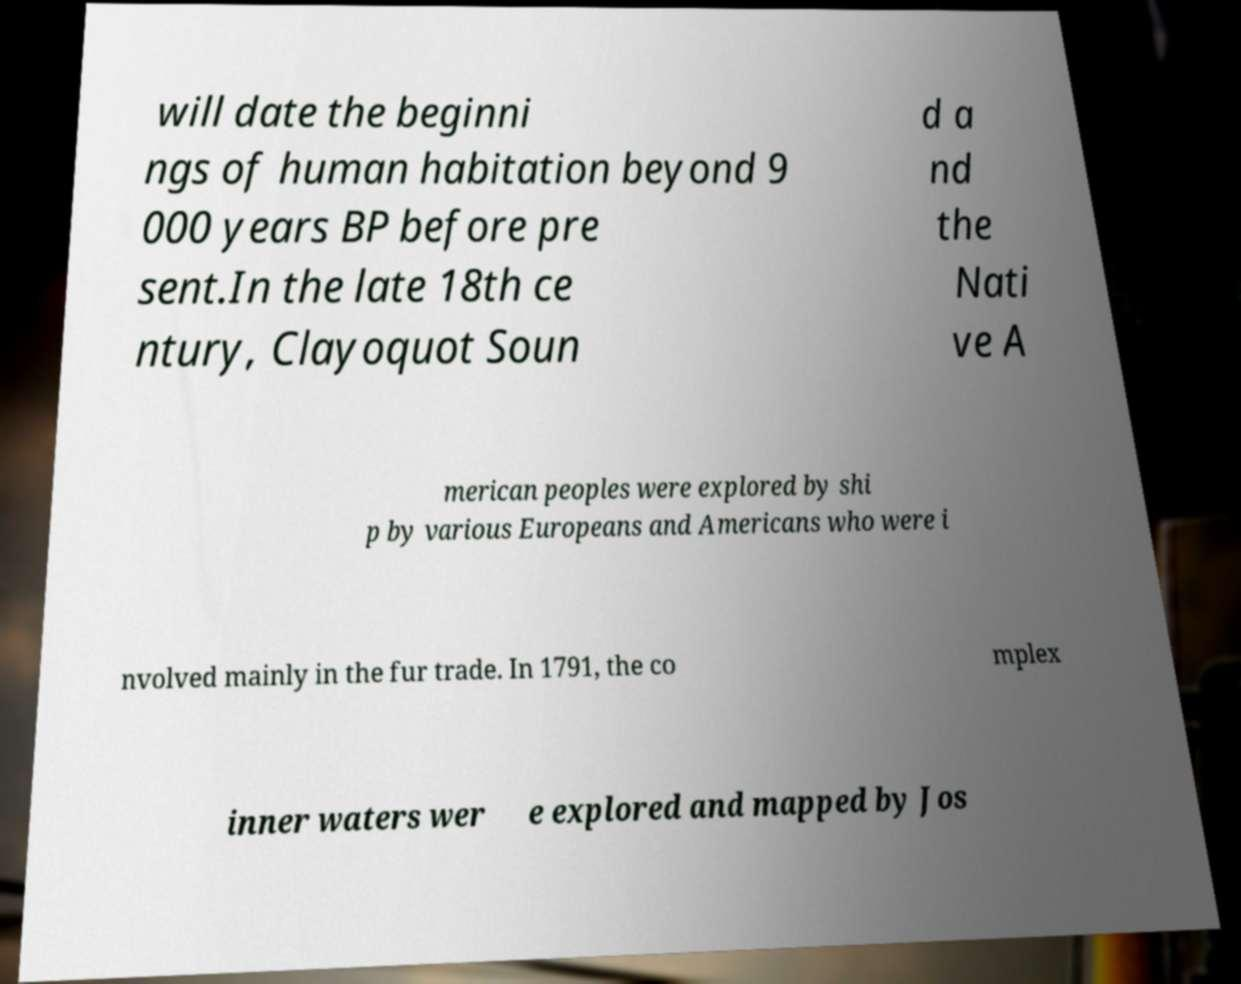Could you extract and type out the text from this image? will date the beginni ngs of human habitation beyond 9 000 years BP before pre sent.In the late 18th ce ntury, Clayoquot Soun d a nd the Nati ve A merican peoples were explored by shi p by various Europeans and Americans who were i nvolved mainly in the fur trade. In 1791, the co mplex inner waters wer e explored and mapped by Jos 